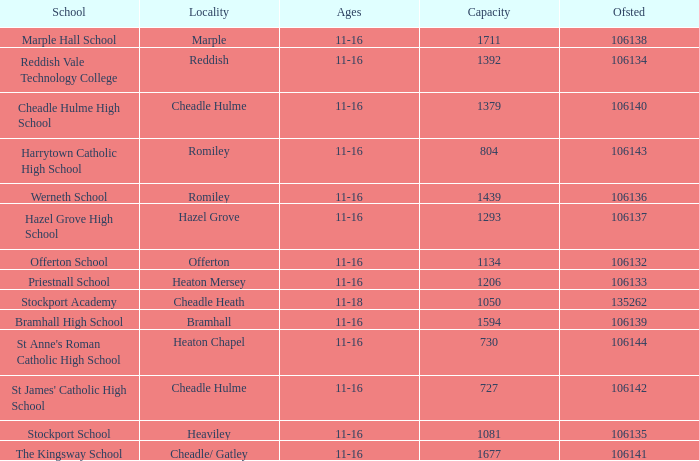Which Ofsted has a Capacity of 1677? 106141.0. 